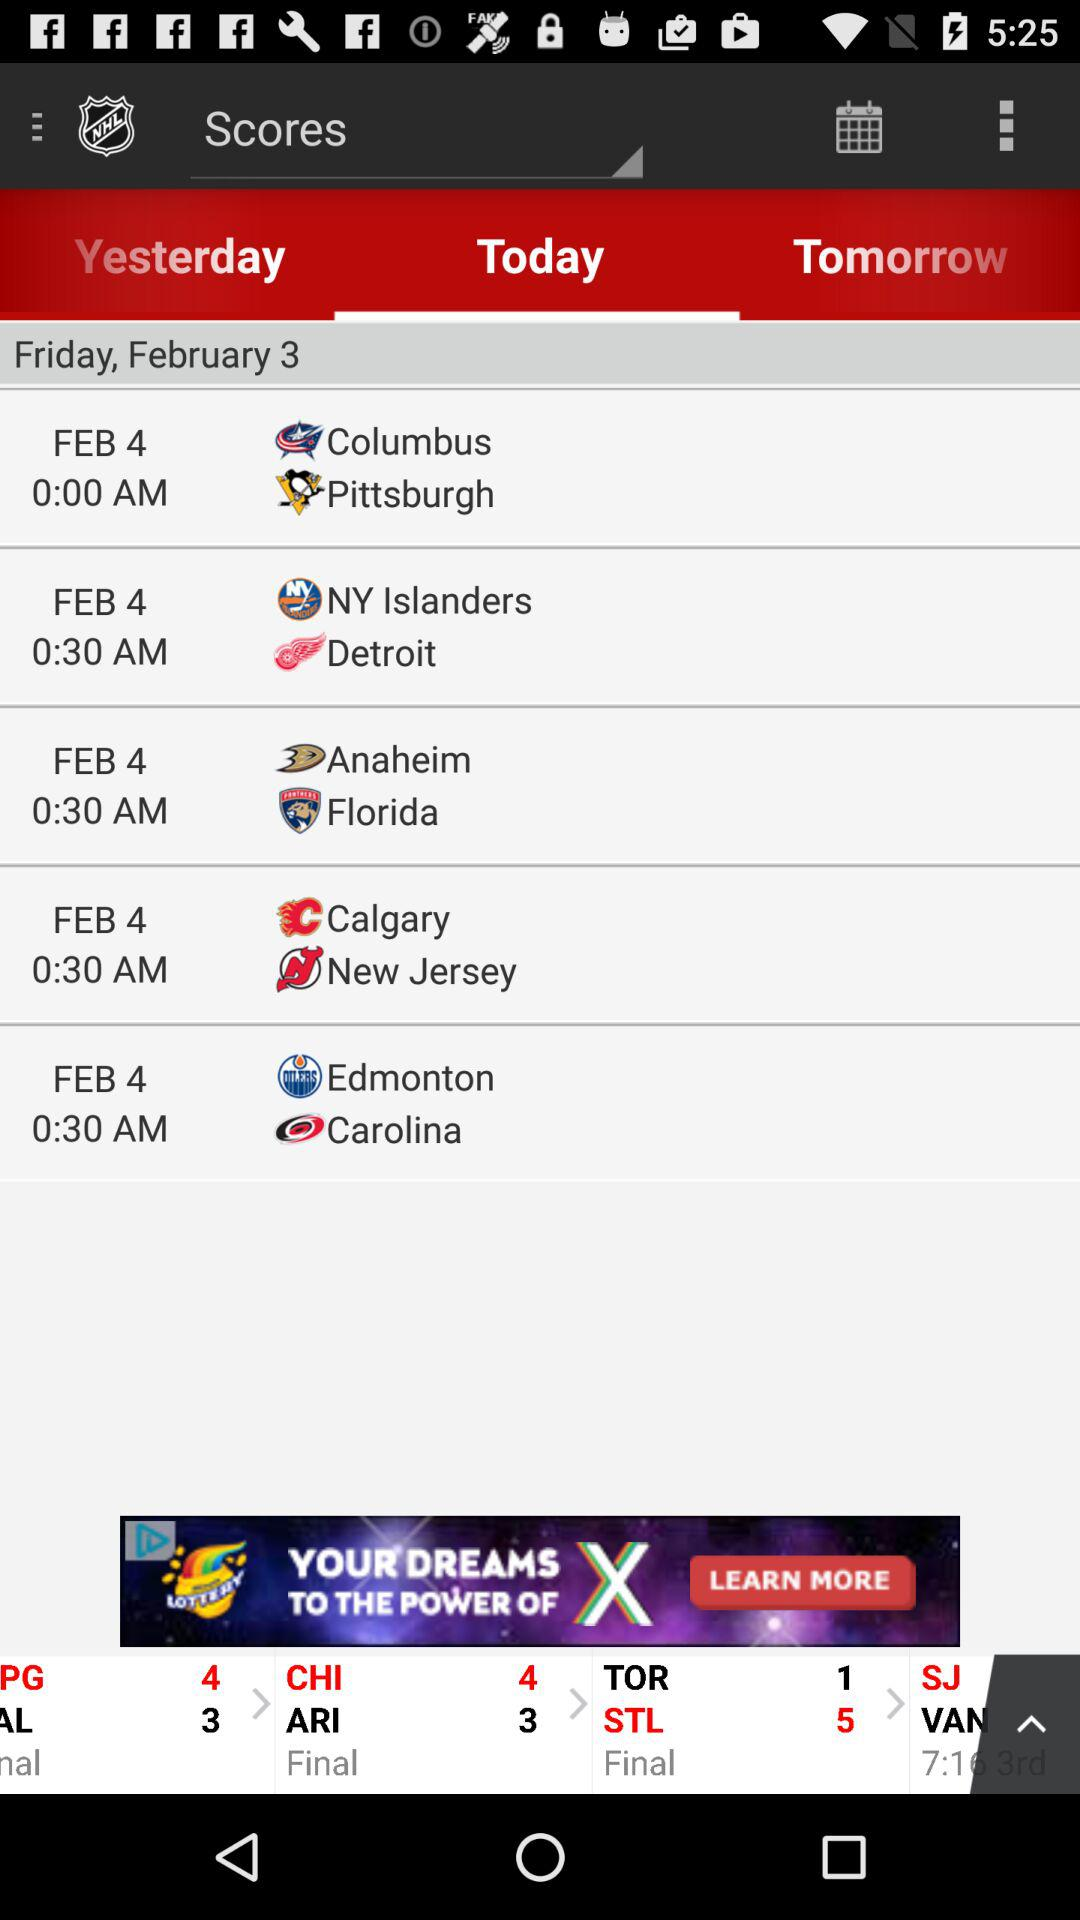What is the mentioned date? The mentioned dates are Friday, February 3 and February 4. 